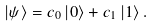<formula> <loc_0><loc_0><loc_500><loc_500>| { \psi } \rangle = c _ { 0 } \, | { 0 } \rangle + c _ { 1 } \, | { 1 } \rangle \, .</formula> 